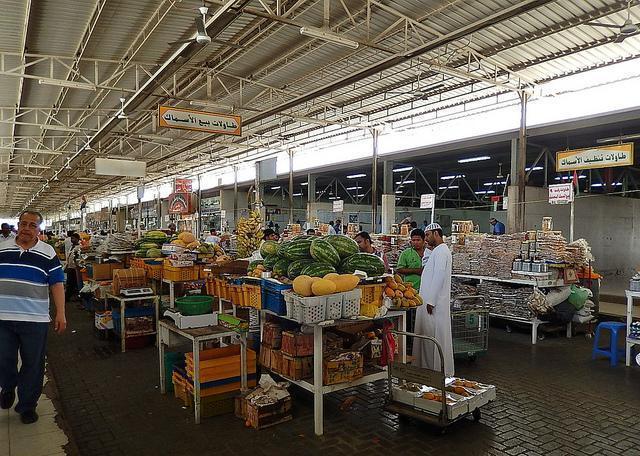What part of the market is located here?
Answer the question by selecting the correct answer among the 4 following choices and explain your choice with a short sentence. The answer should be formatted with the following format: `Answer: choice
Rationale: rationale.`
Options: Fruit stand, custom packaging, home wares, butcher. Answer: fruit stand.
Rationale: There are melons, bananas and other produce available for sale. 